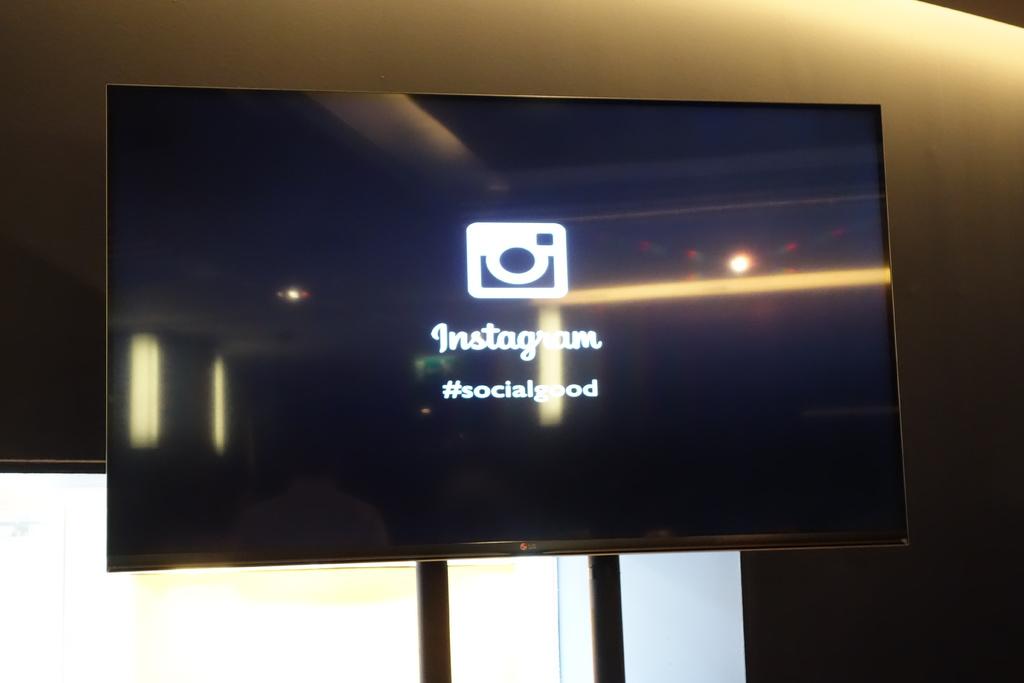What word follows the hashtag?
Your response must be concise. Socialgood. What platform is shown on the imagge?
Keep it short and to the point. Instagram. 